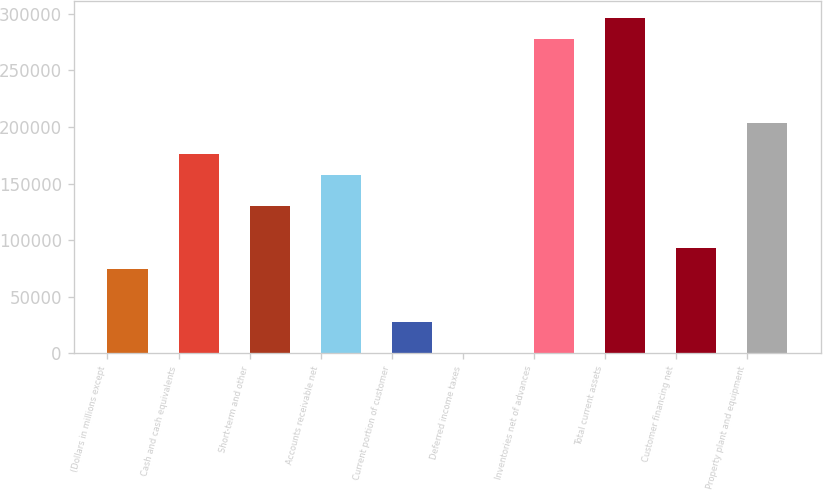<chart> <loc_0><loc_0><loc_500><loc_500><bar_chart><fcel>(Dollars in millions except<fcel>Cash and cash equivalents<fcel>Short-term and other<fcel>Accounts receivable net<fcel>Current portion of customer<fcel>Deferred income taxes<fcel>Inventories net of advances<fcel>Total current assets<fcel>Customer financing net<fcel>Property plant and equipment<nl><fcel>74133.2<fcel>176047<fcel>129723<fcel>157517<fcel>27808.7<fcel>14<fcel>277961<fcel>296491<fcel>92663<fcel>203842<nl></chart> 